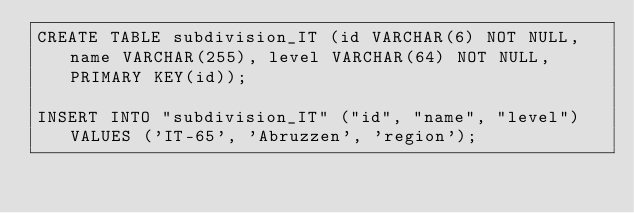Convert code to text. <code><loc_0><loc_0><loc_500><loc_500><_SQL_>CREATE TABLE subdivision_IT (id VARCHAR(6) NOT NULL, name VARCHAR(255), level VARCHAR(64) NOT NULL, PRIMARY KEY(id));

INSERT INTO "subdivision_IT" ("id", "name", "level") VALUES ('IT-65', 'Abruzzen', 'region');</code> 